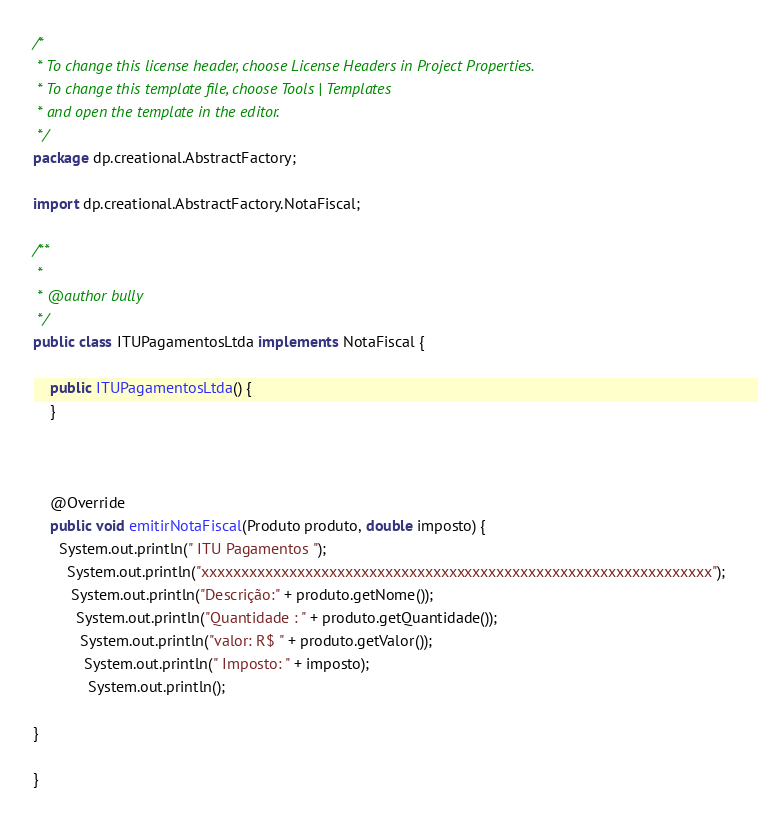Convert code to text. <code><loc_0><loc_0><loc_500><loc_500><_Java_>/*
 * To change this license header, choose License Headers in Project Properties.
 * To change this template file, choose Tools | Templates
 * and open the template in the editor.
 */
package dp.creational.AbstractFactory;

import dp.creational.AbstractFactory.NotaFiscal;

/**
 *
 * @author bully
 */
public class ITUPagamentosLtda implements NotaFiscal {

    public ITUPagamentosLtda() {
    }
 
    

    @Override
    public void emitirNotaFiscal(Produto produto, double imposto) {
      System.out.println(" ITU Pagamentos ");
        System.out.println("xxxxxxxxxxxxxxxxxxxxxxxxxxxxxxxxxxxxxxxxxxxxxxxxxxxxxxxxxxxxxxxx");
         System.out.println("Descrição:" + produto.getNome());
          System.out.println("Quantidade : " + produto.getQuantidade());
           System.out.println("valor: R$ " + produto.getValor());
            System.out.println(" Imposto: " + imposto);
             System.out.println(); 
    
}

}</code> 